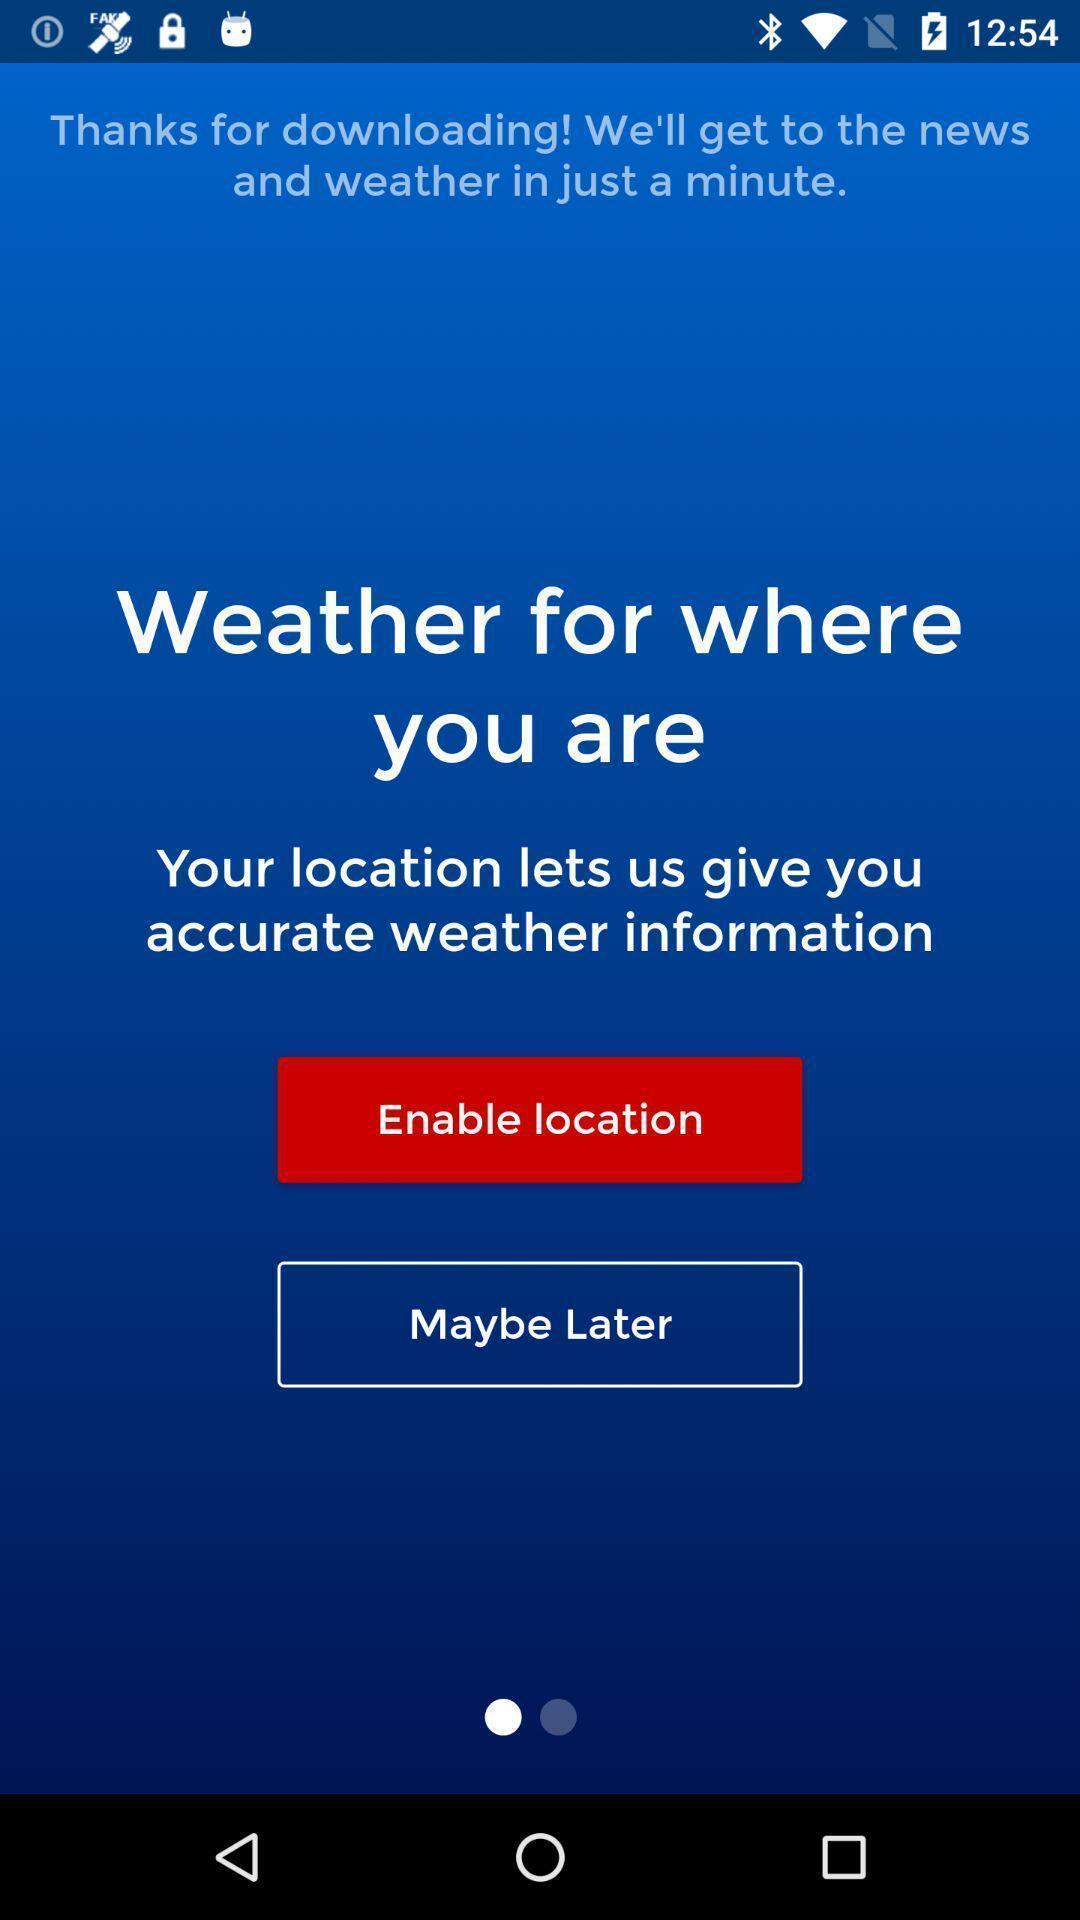What is the overall content of this screenshot? Welcome page of a weather application. 